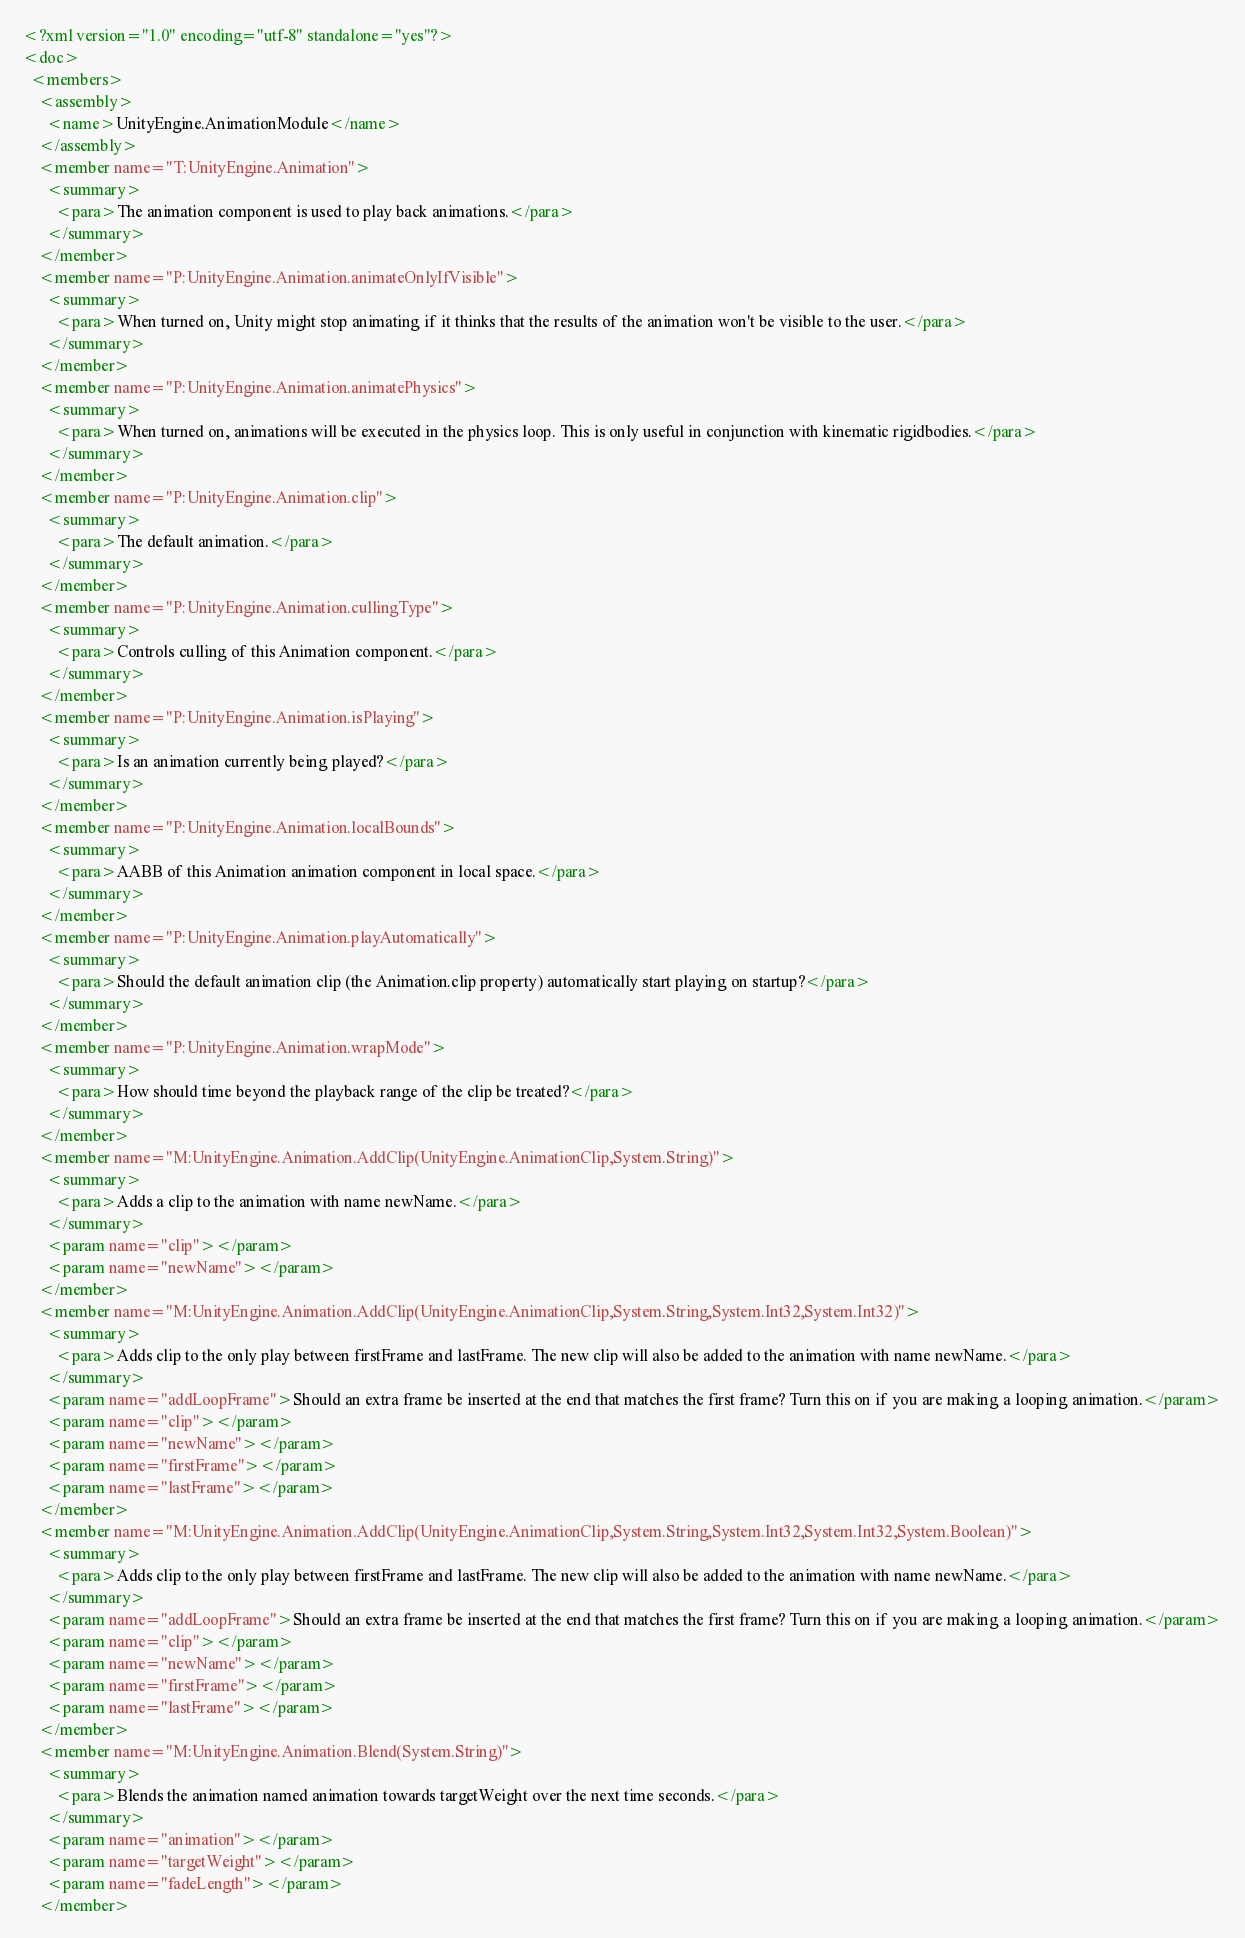<code> <loc_0><loc_0><loc_500><loc_500><_XML_><?xml version="1.0" encoding="utf-8" standalone="yes"?>
<doc>
  <members>
    <assembly>
      <name>UnityEngine.AnimationModule</name>
    </assembly>
    <member name="T:UnityEngine.Animation">
      <summary>
        <para>The animation component is used to play back animations.</para>
      </summary>
    </member>
    <member name="P:UnityEngine.Animation.animateOnlyIfVisible">
      <summary>
        <para>When turned on, Unity might stop animating if it thinks that the results of the animation won't be visible to the user.</para>
      </summary>
    </member>
    <member name="P:UnityEngine.Animation.animatePhysics">
      <summary>
        <para>When turned on, animations will be executed in the physics loop. This is only useful in conjunction with kinematic rigidbodies.</para>
      </summary>
    </member>
    <member name="P:UnityEngine.Animation.clip">
      <summary>
        <para>The default animation.</para>
      </summary>
    </member>
    <member name="P:UnityEngine.Animation.cullingType">
      <summary>
        <para>Controls culling of this Animation component.</para>
      </summary>
    </member>
    <member name="P:UnityEngine.Animation.isPlaying">
      <summary>
        <para>Is an animation currently being played?</para>
      </summary>
    </member>
    <member name="P:UnityEngine.Animation.localBounds">
      <summary>
        <para>AABB of this Animation animation component in local space.</para>
      </summary>
    </member>
    <member name="P:UnityEngine.Animation.playAutomatically">
      <summary>
        <para>Should the default animation clip (the Animation.clip property) automatically start playing on startup?</para>
      </summary>
    </member>
    <member name="P:UnityEngine.Animation.wrapMode">
      <summary>
        <para>How should time beyond the playback range of the clip be treated?</para>
      </summary>
    </member>
    <member name="M:UnityEngine.Animation.AddClip(UnityEngine.AnimationClip,System.String)">
      <summary>
        <para>Adds a clip to the animation with name newName.</para>
      </summary>
      <param name="clip"></param>
      <param name="newName"></param>
    </member>
    <member name="M:UnityEngine.Animation.AddClip(UnityEngine.AnimationClip,System.String,System.Int32,System.Int32)">
      <summary>
        <para>Adds clip to the only play between firstFrame and lastFrame. The new clip will also be added to the animation with name newName.</para>
      </summary>
      <param name="addLoopFrame">Should an extra frame be inserted at the end that matches the first frame? Turn this on if you are making a looping animation.</param>
      <param name="clip"></param>
      <param name="newName"></param>
      <param name="firstFrame"></param>
      <param name="lastFrame"></param>
    </member>
    <member name="M:UnityEngine.Animation.AddClip(UnityEngine.AnimationClip,System.String,System.Int32,System.Int32,System.Boolean)">
      <summary>
        <para>Adds clip to the only play between firstFrame and lastFrame. The new clip will also be added to the animation with name newName.</para>
      </summary>
      <param name="addLoopFrame">Should an extra frame be inserted at the end that matches the first frame? Turn this on if you are making a looping animation.</param>
      <param name="clip"></param>
      <param name="newName"></param>
      <param name="firstFrame"></param>
      <param name="lastFrame"></param>
    </member>
    <member name="M:UnityEngine.Animation.Blend(System.String)">
      <summary>
        <para>Blends the animation named animation towards targetWeight over the next time seconds.</para>
      </summary>
      <param name="animation"></param>
      <param name="targetWeight"></param>
      <param name="fadeLength"></param>
    </member></code> 